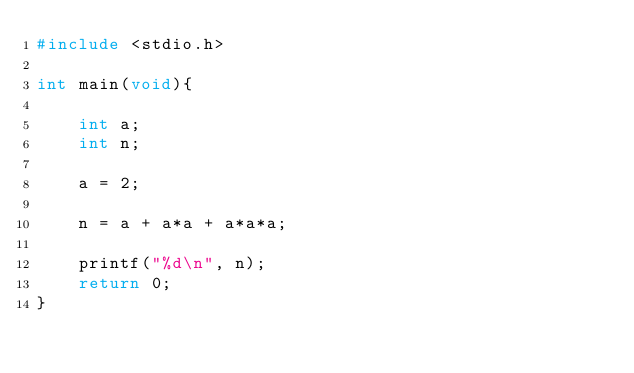Convert code to text. <code><loc_0><loc_0><loc_500><loc_500><_C_>#include <stdio.h>

int main(void){

    int a;
    int n;

    a = 2;

    n = a + a*a + a*a*a;

    printf("%d\n", n);
    return 0;
}</code> 